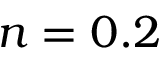<formula> <loc_0><loc_0><loc_500><loc_500>n = 0 . 2</formula> 